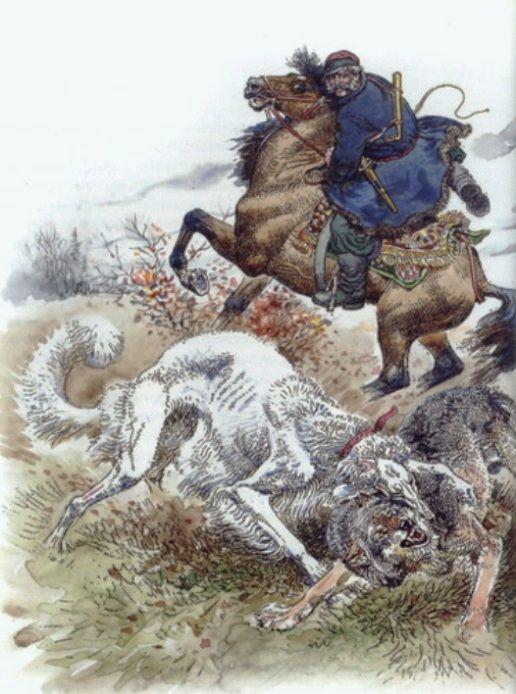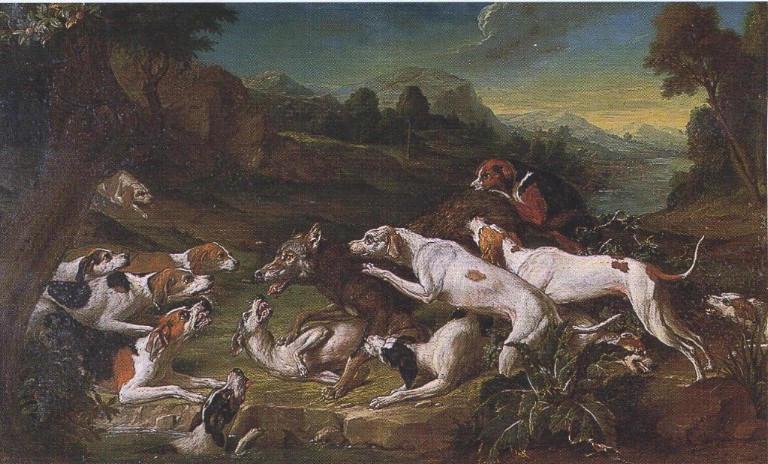The first image is the image on the left, the second image is the image on the right. Evaluate the accuracy of this statement regarding the images: "An image features a horse rearing up with raised front legs, behind multiple dogs.". Is it true? Answer yes or no. Yes. The first image is the image on the left, the second image is the image on the right. Given the left and right images, does the statement "In one of the images there is a man sitting on top of a dog." hold true? Answer yes or no. No. 